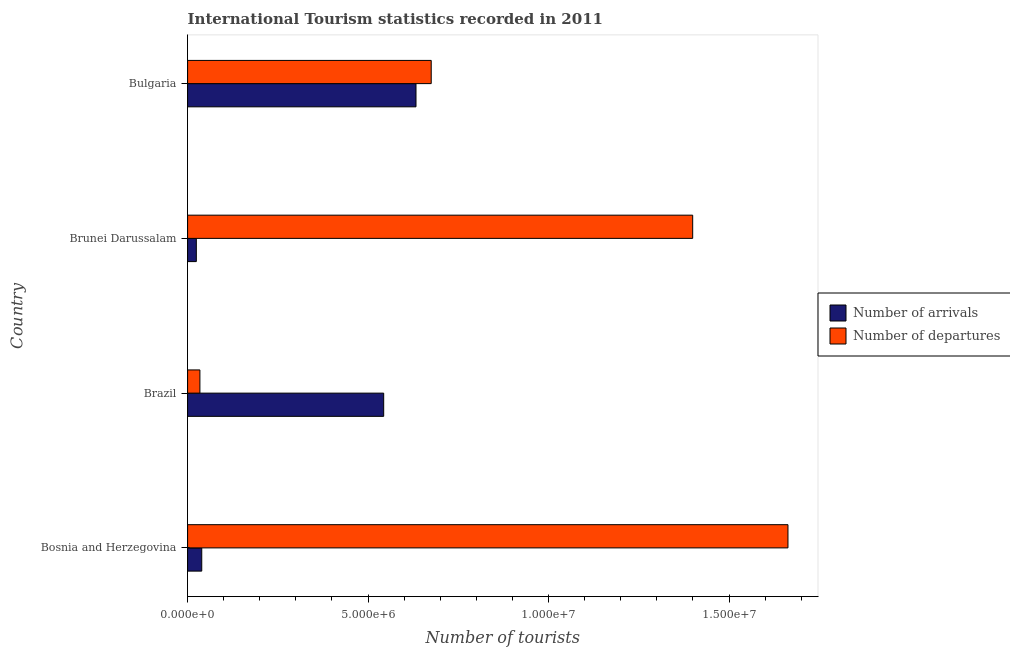How many different coloured bars are there?
Give a very brief answer. 2. How many groups of bars are there?
Offer a terse response. 4. Are the number of bars per tick equal to the number of legend labels?
Provide a succinct answer. Yes. What is the label of the 2nd group of bars from the top?
Your response must be concise. Brunei Darussalam. In how many cases, is the number of bars for a given country not equal to the number of legend labels?
Keep it short and to the point. 0. What is the number of tourist departures in Bosnia and Herzegovina?
Provide a succinct answer. 1.66e+07. Across all countries, what is the maximum number of tourist arrivals?
Give a very brief answer. 6.33e+06. Across all countries, what is the minimum number of tourist departures?
Your answer should be compact. 3.41e+05. In which country was the number of tourist departures maximum?
Your response must be concise. Bosnia and Herzegovina. In which country was the number of tourist departures minimum?
Keep it short and to the point. Brazil. What is the total number of tourist arrivals in the graph?
Ensure brevity in your answer.  1.24e+07. What is the difference between the number of tourist arrivals in Brunei Darussalam and that in Bulgaria?
Ensure brevity in your answer.  -6.09e+06. What is the difference between the number of tourist arrivals in Bosnia and Herzegovina and the number of tourist departures in Brunei Darussalam?
Offer a very short reply. -1.36e+07. What is the average number of tourist departures per country?
Your answer should be compact. 9.43e+06. What is the difference between the number of tourist departures and number of tourist arrivals in Bulgaria?
Provide a short and direct response. 4.22e+05. In how many countries, is the number of tourist arrivals greater than 8000000 ?
Offer a terse response. 0. What is the ratio of the number of tourist arrivals in Brunei Darussalam to that in Bulgaria?
Provide a short and direct response. 0.04. Is the difference between the number of tourist departures in Bosnia and Herzegovina and Bulgaria greater than the difference between the number of tourist arrivals in Bosnia and Herzegovina and Bulgaria?
Give a very brief answer. Yes. What is the difference between the highest and the second highest number of tourist departures?
Give a very brief answer. 2.64e+06. What is the difference between the highest and the lowest number of tourist departures?
Provide a short and direct response. 1.63e+07. Is the sum of the number of tourist departures in Bosnia and Herzegovina and Brunei Darussalam greater than the maximum number of tourist arrivals across all countries?
Offer a very short reply. Yes. What does the 1st bar from the top in Bulgaria represents?
Your answer should be compact. Number of departures. What does the 2nd bar from the bottom in Bulgaria represents?
Your response must be concise. Number of departures. How many bars are there?
Your answer should be very brief. 8. Are all the bars in the graph horizontal?
Your response must be concise. Yes. Are the values on the major ticks of X-axis written in scientific E-notation?
Provide a succinct answer. Yes. Does the graph contain any zero values?
Your answer should be compact. No. Where does the legend appear in the graph?
Offer a very short reply. Center right. How many legend labels are there?
Make the answer very short. 2. How are the legend labels stacked?
Offer a very short reply. Vertical. What is the title of the graph?
Provide a succinct answer. International Tourism statistics recorded in 2011. Does "Broad money growth" appear as one of the legend labels in the graph?
Ensure brevity in your answer.  No. What is the label or title of the X-axis?
Offer a very short reply. Number of tourists. What is the label or title of the Y-axis?
Ensure brevity in your answer.  Country. What is the Number of tourists of Number of arrivals in Bosnia and Herzegovina?
Give a very brief answer. 3.92e+05. What is the Number of tourists of Number of departures in Bosnia and Herzegovina?
Offer a terse response. 1.66e+07. What is the Number of tourists of Number of arrivals in Brazil?
Provide a short and direct response. 5.43e+06. What is the Number of tourists of Number of departures in Brazil?
Provide a short and direct response. 3.41e+05. What is the Number of tourists in Number of arrivals in Brunei Darussalam?
Your answer should be very brief. 2.42e+05. What is the Number of tourists in Number of departures in Brunei Darussalam?
Offer a terse response. 1.40e+07. What is the Number of tourists of Number of arrivals in Bulgaria?
Keep it short and to the point. 6.33e+06. What is the Number of tourists of Number of departures in Bulgaria?
Offer a terse response. 6.75e+06. Across all countries, what is the maximum Number of tourists of Number of arrivals?
Ensure brevity in your answer.  6.33e+06. Across all countries, what is the maximum Number of tourists in Number of departures?
Your answer should be compact. 1.66e+07. Across all countries, what is the minimum Number of tourists of Number of arrivals?
Offer a terse response. 2.42e+05. Across all countries, what is the minimum Number of tourists of Number of departures?
Ensure brevity in your answer.  3.41e+05. What is the total Number of tourists in Number of arrivals in the graph?
Ensure brevity in your answer.  1.24e+07. What is the total Number of tourists of Number of departures in the graph?
Ensure brevity in your answer.  3.77e+07. What is the difference between the Number of tourists of Number of arrivals in Bosnia and Herzegovina and that in Brazil?
Your response must be concise. -5.04e+06. What is the difference between the Number of tourists in Number of departures in Bosnia and Herzegovina and that in Brazil?
Your answer should be very brief. 1.63e+07. What is the difference between the Number of tourists in Number of departures in Bosnia and Herzegovina and that in Brunei Darussalam?
Keep it short and to the point. 2.64e+06. What is the difference between the Number of tourists of Number of arrivals in Bosnia and Herzegovina and that in Bulgaria?
Provide a succinct answer. -5.94e+06. What is the difference between the Number of tourists of Number of departures in Bosnia and Herzegovina and that in Bulgaria?
Offer a very short reply. 9.88e+06. What is the difference between the Number of tourists in Number of arrivals in Brazil and that in Brunei Darussalam?
Make the answer very short. 5.19e+06. What is the difference between the Number of tourists in Number of departures in Brazil and that in Brunei Darussalam?
Offer a very short reply. -1.37e+07. What is the difference between the Number of tourists of Number of arrivals in Brazil and that in Bulgaria?
Ensure brevity in your answer.  -8.95e+05. What is the difference between the Number of tourists in Number of departures in Brazil and that in Bulgaria?
Ensure brevity in your answer.  -6.41e+06. What is the difference between the Number of tourists in Number of arrivals in Brunei Darussalam and that in Bulgaria?
Give a very brief answer. -6.09e+06. What is the difference between the Number of tourists of Number of departures in Brunei Darussalam and that in Bulgaria?
Provide a succinct answer. 7.24e+06. What is the difference between the Number of tourists in Number of arrivals in Bosnia and Herzegovina and the Number of tourists in Number of departures in Brazil?
Make the answer very short. 5.10e+04. What is the difference between the Number of tourists of Number of arrivals in Bosnia and Herzegovina and the Number of tourists of Number of departures in Brunei Darussalam?
Your response must be concise. -1.36e+07. What is the difference between the Number of tourists of Number of arrivals in Bosnia and Herzegovina and the Number of tourists of Number of departures in Bulgaria?
Offer a terse response. -6.36e+06. What is the difference between the Number of tourists in Number of arrivals in Brazil and the Number of tourists in Number of departures in Brunei Darussalam?
Offer a terse response. -8.56e+06. What is the difference between the Number of tourists of Number of arrivals in Brazil and the Number of tourists of Number of departures in Bulgaria?
Provide a succinct answer. -1.32e+06. What is the difference between the Number of tourists in Number of arrivals in Brunei Darussalam and the Number of tourists in Number of departures in Bulgaria?
Your answer should be compact. -6.51e+06. What is the average Number of tourists in Number of arrivals per country?
Keep it short and to the point. 3.10e+06. What is the average Number of tourists of Number of departures per country?
Offer a terse response. 9.43e+06. What is the difference between the Number of tourists in Number of arrivals and Number of tourists in Number of departures in Bosnia and Herzegovina?
Your response must be concise. -1.62e+07. What is the difference between the Number of tourists of Number of arrivals and Number of tourists of Number of departures in Brazil?
Your answer should be compact. 5.09e+06. What is the difference between the Number of tourists in Number of arrivals and Number of tourists in Number of departures in Brunei Darussalam?
Your answer should be very brief. -1.38e+07. What is the difference between the Number of tourists in Number of arrivals and Number of tourists in Number of departures in Bulgaria?
Keep it short and to the point. -4.22e+05. What is the ratio of the Number of tourists of Number of arrivals in Bosnia and Herzegovina to that in Brazil?
Your response must be concise. 0.07. What is the ratio of the Number of tourists of Number of departures in Bosnia and Herzegovina to that in Brazil?
Your response must be concise. 48.78. What is the ratio of the Number of tourists in Number of arrivals in Bosnia and Herzegovina to that in Brunei Darussalam?
Ensure brevity in your answer.  1.62. What is the ratio of the Number of tourists in Number of departures in Bosnia and Herzegovina to that in Brunei Darussalam?
Provide a succinct answer. 1.19. What is the ratio of the Number of tourists in Number of arrivals in Bosnia and Herzegovina to that in Bulgaria?
Your answer should be compact. 0.06. What is the ratio of the Number of tourists of Number of departures in Bosnia and Herzegovina to that in Bulgaria?
Keep it short and to the point. 2.46. What is the ratio of the Number of tourists in Number of arrivals in Brazil to that in Brunei Darussalam?
Provide a short and direct response. 22.45. What is the ratio of the Number of tourists of Number of departures in Brazil to that in Brunei Darussalam?
Make the answer very short. 0.02. What is the ratio of the Number of tourists of Number of arrivals in Brazil to that in Bulgaria?
Offer a terse response. 0.86. What is the ratio of the Number of tourists of Number of departures in Brazil to that in Bulgaria?
Ensure brevity in your answer.  0.05. What is the ratio of the Number of tourists of Number of arrivals in Brunei Darussalam to that in Bulgaria?
Provide a short and direct response. 0.04. What is the ratio of the Number of tourists in Number of departures in Brunei Darussalam to that in Bulgaria?
Your answer should be compact. 2.07. What is the difference between the highest and the second highest Number of tourists of Number of arrivals?
Ensure brevity in your answer.  8.95e+05. What is the difference between the highest and the second highest Number of tourists in Number of departures?
Offer a very short reply. 2.64e+06. What is the difference between the highest and the lowest Number of tourists in Number of arrivals?
Ensure brevity in your answer.  6.09e+06. What is the difference between the highest and the lowest Number of tourists in Number of departures?
Keep it short and to the point. 1.63e+07. 